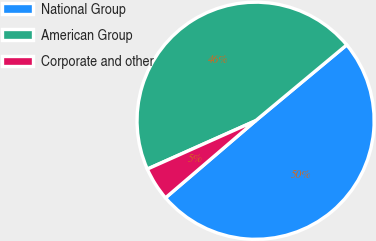<chart> <loc_0><loc_0><loc_500><loc_500><pie_chart><fcel>National Group<fcel>American Group<fcel>Corporate and other<nl><fcel>49.78%<fcel>45.64%<fcel>4.58%<nl></chart> 